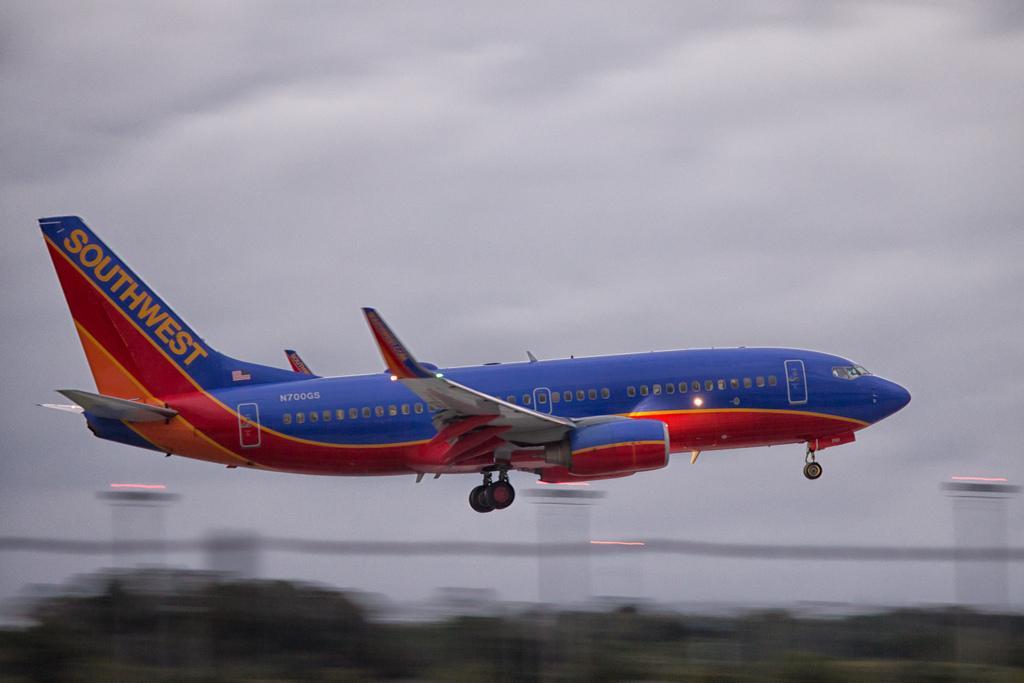Can you describe this image briefly? In the center of the image we can see one airplane with a multi color. And we can see some text on the airplane. In the background, we can see the sky, clouds and a few other objects. 